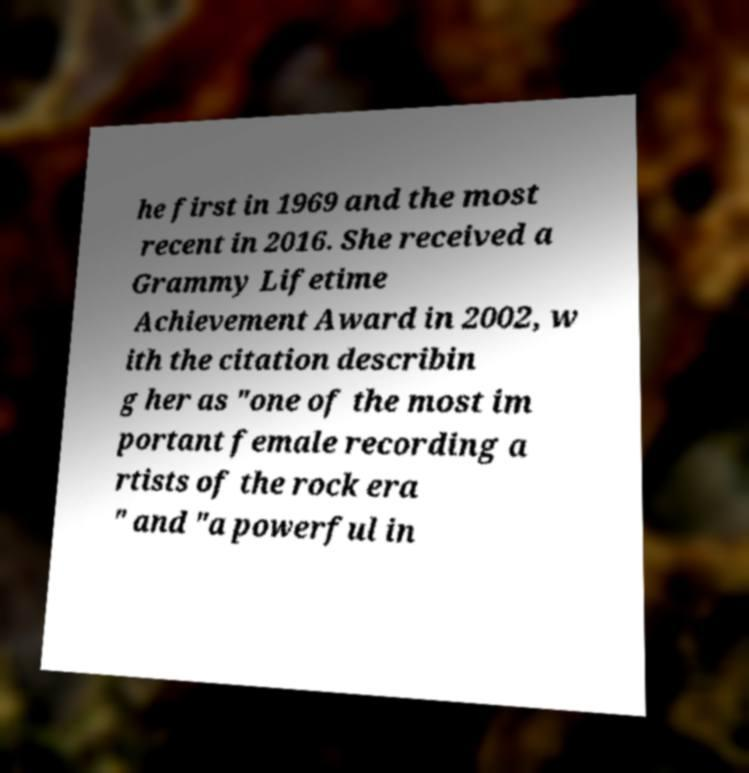Please read and relay the text visible in this image. What does it say? he first in 1969 and the most recent in 2016. She received a Grammy Lifetime Achievement Award in 2002, w ith the citation describin g her as "one of the most im portant female recording a rtists of the rock era " and "a powerful in 